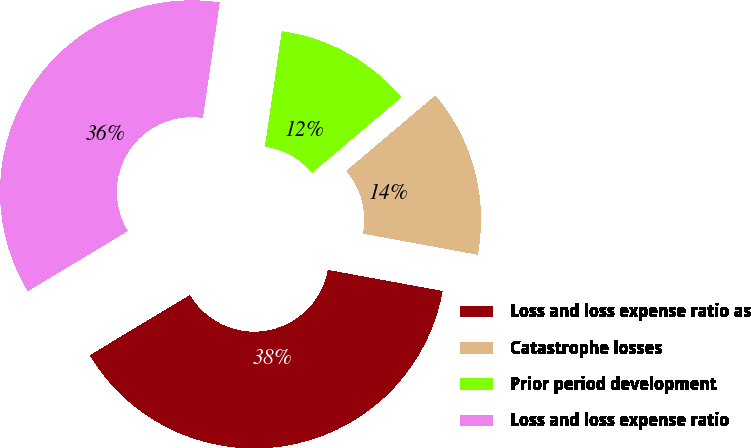<chart> <loc_0><loc_0><loc_500><loc_500><pie_chart><fcel>Loss and loss expense ratio as<fcel>Catastrophe losses<fcel>Prior period development<fcel>Loss and loss expense ratio<nl><fcel>38.48%<fcel>14.07%<fcel>11.52%<fcel>35.93%<nl></chart> 